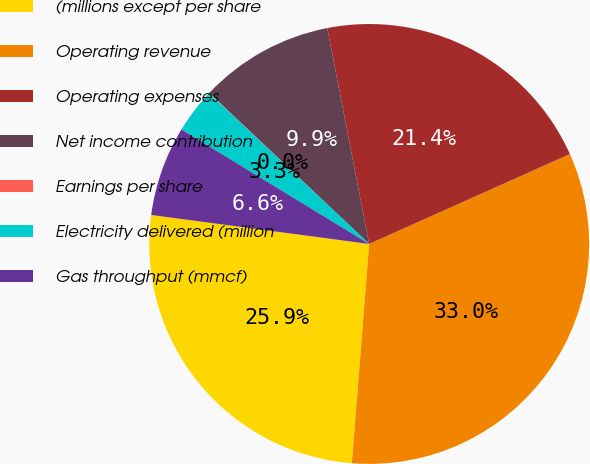<chart> <loc_0><loc_0><loc_500><loc_500><pie_chart><fcel>(millions except per share<fcel>Operating revenue<fcel>Operating expenses<fcel>Net income contribution<fcel>Earnings per share<fcel>Electricity delivered (million<fcel>Gas throughput (mmcf)<nl><fcel>25.85%<fcel>32.96%<fcel>21.35%<fcel>9.9%<fcel>0.02%<fcel>3.31%<fcel>6.61%<nl></chart> 